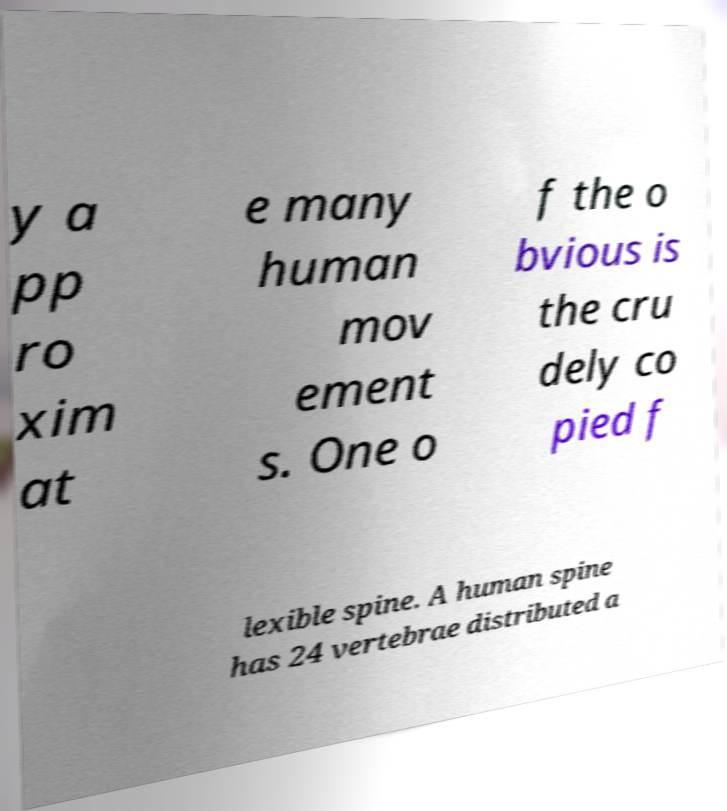What messages or text are displayed in this image? I need them in a readable, typed format. y a pp ro xim at e many human mov ement s. One o f the o bvious is the cru dely co pied f lexible spine. A human spine has 24 vertebrae distributed a 